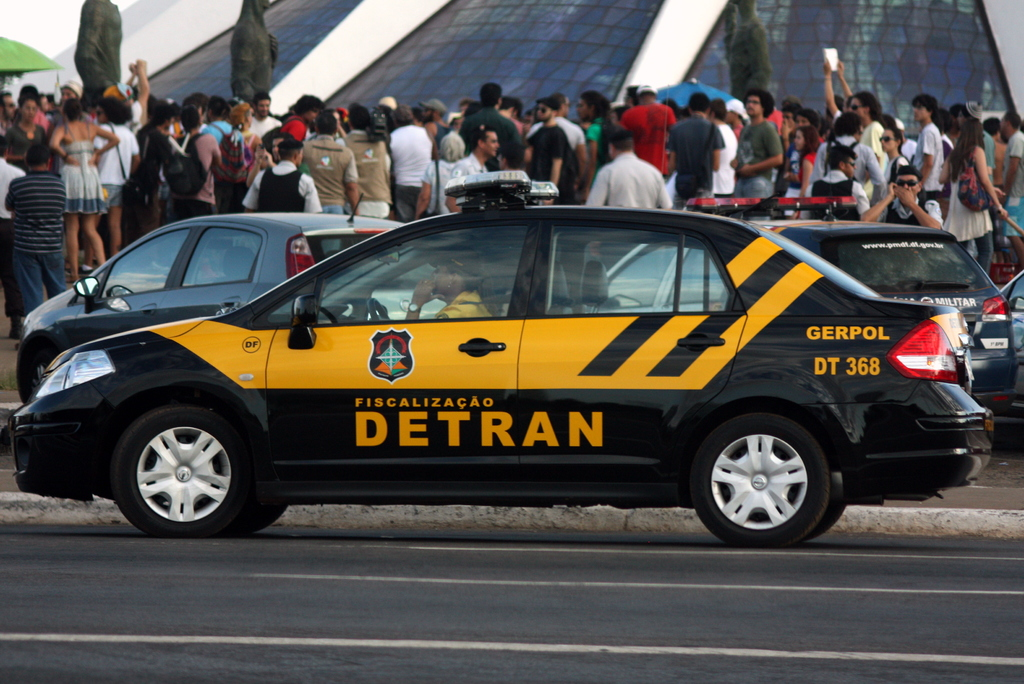What kind of event might be taking place around this DETRAN vehicle? Given the large crowd visible around the DETRAN vehicle, it could be overseeing a public event, perhaps a festival or a crowded market day, ensuring safety and regulatory compliance. 